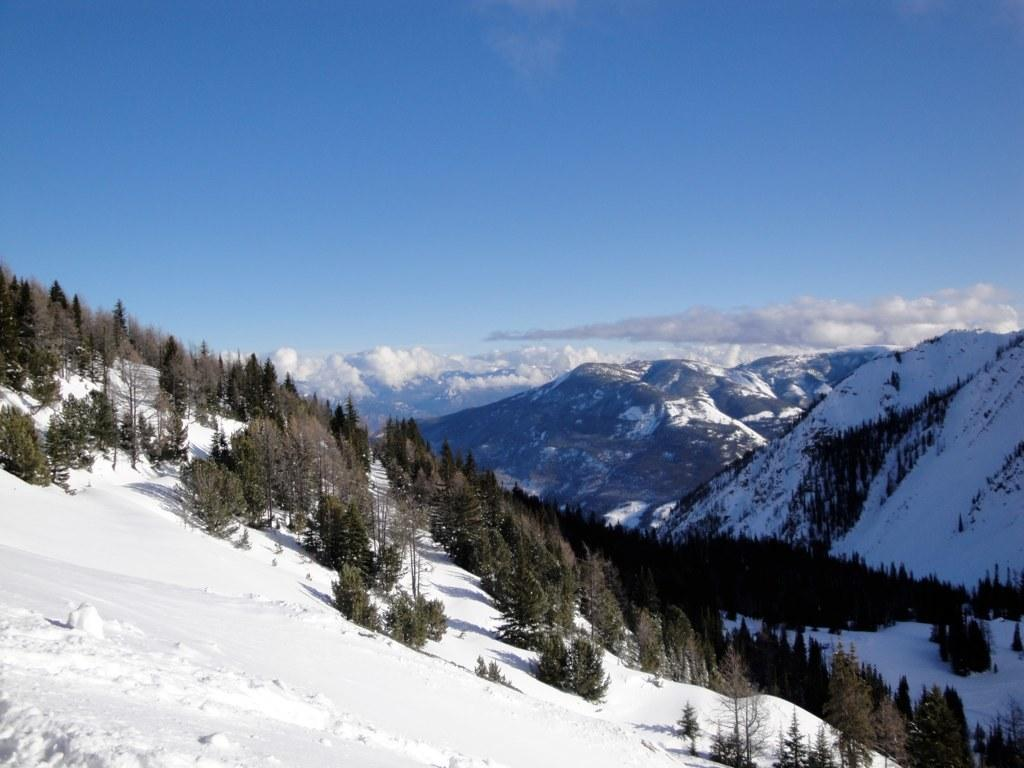What type of vegetation can be seen in the image? There are trees in the image. What geographical features are present in the image? There are hills in the image. What is visible in the sky in the image? The sky is visible in the image, and clouds are present. What is the ground covered with in the image? There is snow on the ground in the image. Can you see a horse running through the snow in the image? There is no horse present in the image. What direction is the wind blowing in the image? There is no indication of wind direction in the image. 